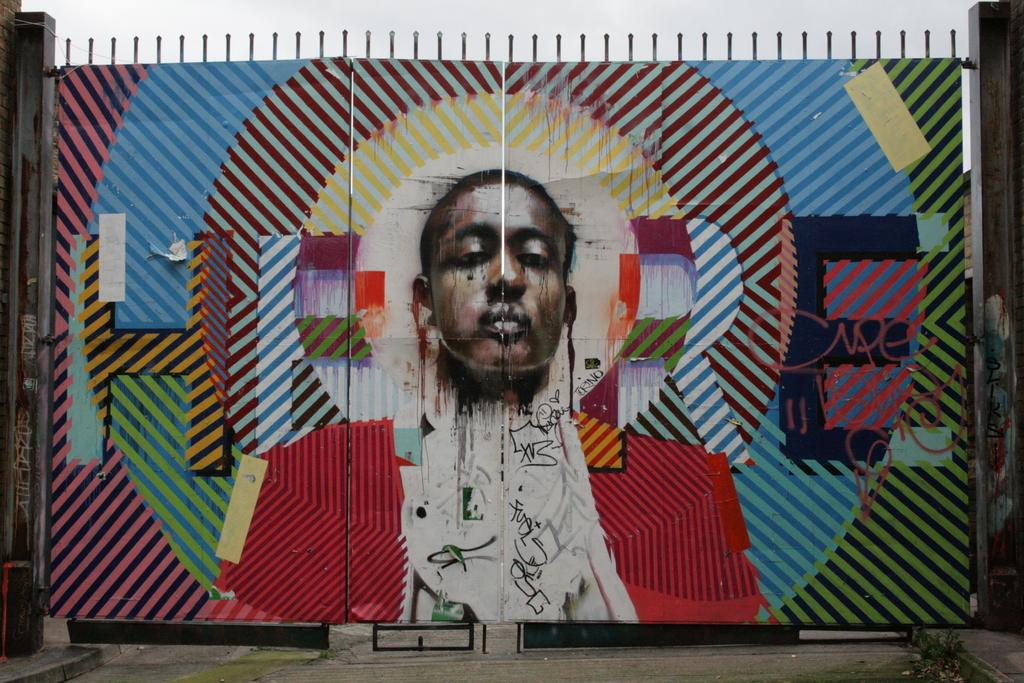What is the main structure visible in the image? There is a huge metal gate in the image. What decorative element is present on the gate? There is a colorful painting on the gate. What can be seen in the background of the image? The sky is visible in the background of the image. How many feet are visible on the gate in the image? There are no feet visible on the gate in the image. What type of gold ornamentation is present on the gate? There is no gold ornamentation present on the gate in the image. 